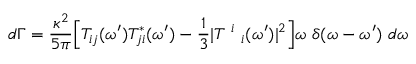Convert formula to latex. <formula><loc_0><loc_0><loc_500><loc_500>d \Gamma = \frac { \kappa ^ { 2 } } { 5 \pi } \left [ T _ { i j } ( \omega ^ { \prime } ) T _ { j i } ^ { * } ( \omega ^ { \prime } ) - \frac { 1 } { 3 } | T ^ { i } _ { i } ( \omega ^ { \prime } ) | ^ { 2 } \right ] \omega \delta ( \omega - \omega ^ { \prime } ) d \omega</formula> 